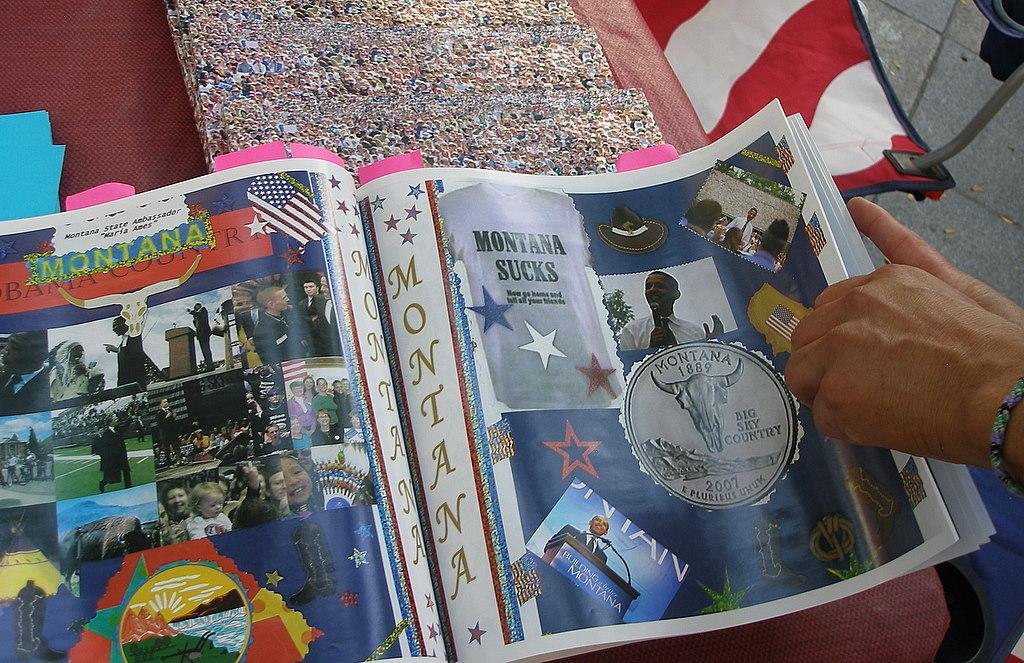Provide a one-sentence caption for the provided image. A magazine with an ad for Montana has a picture of Obama with a sign that reads Build a better Montana. 